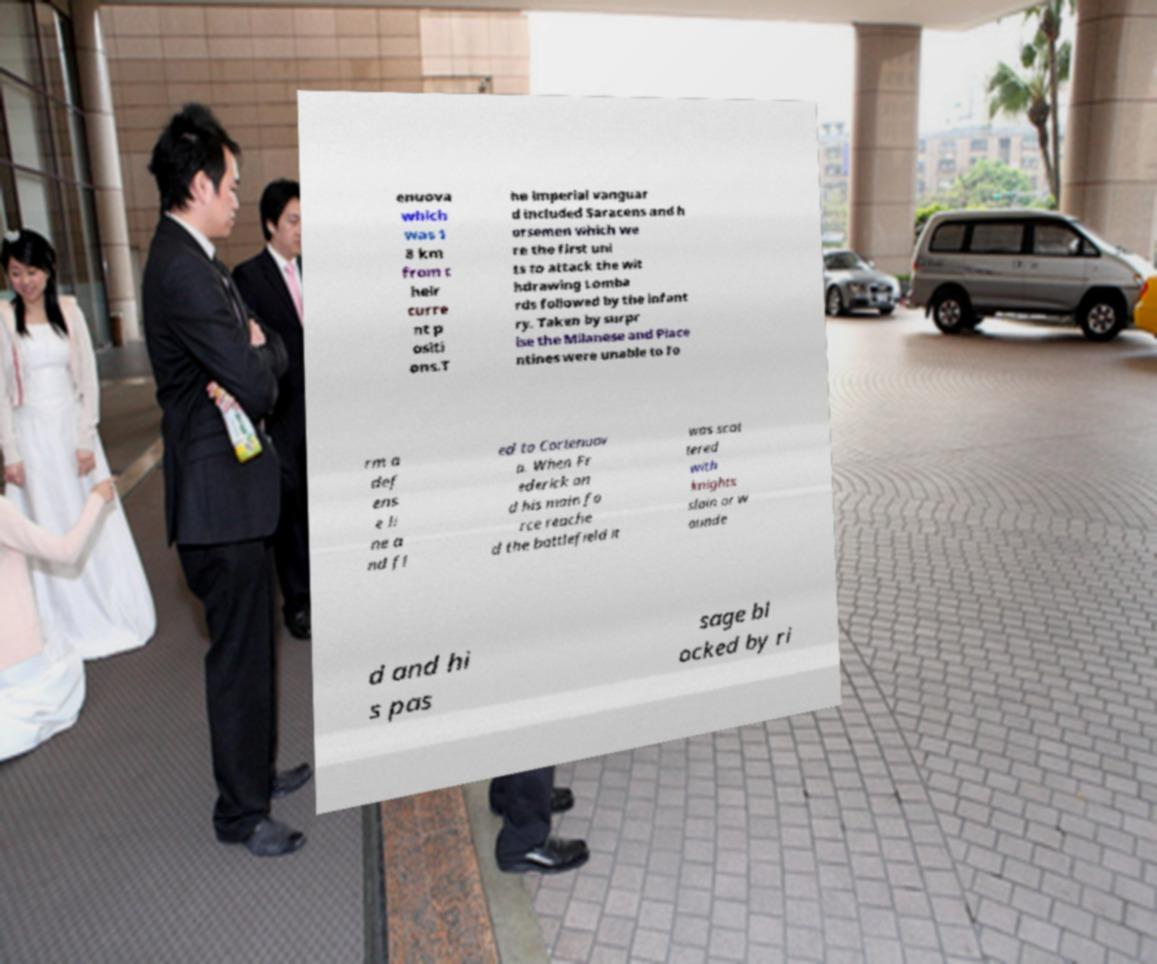For documentation purposes, I need the text within this image transcribed. Could you provide that? enuova which was 1 8 km from t heir curre nt p ositi ons.T he imperial vanguar d included Saracens and h orsemen which we re the first uni ts to attack the wit hdrawing Lomba rds followed by the infant ry. Taken by surpr ise the Milanese and Piace ntines were unable to fo rm a def ens e li ne a nd fl ed to Cortenuov a. When Fr ederick an d his main fo rce reache d the battlefield it was scat tered with knights slain or w ounde d and hi s pas sage bl ocked by ri 